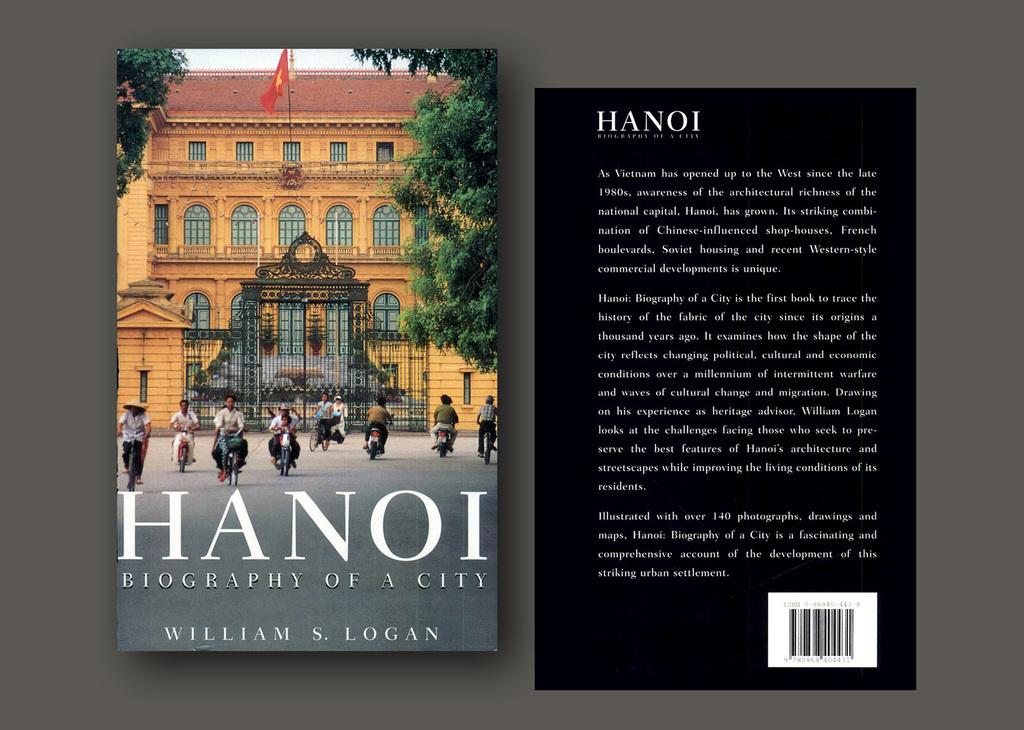<image>
Summarize the visual content of the image. Front and back covers of HANOI book by William Logan. 